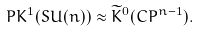Convert formula to latex. <formula><loc_0><loc_0><loc_500><loc_500>P K ^ { 1 } ( S U ( n ) ) \approx \widetilde { K } ^ { 0 } ( C P ^ { n - 1 } ) .</formula> 